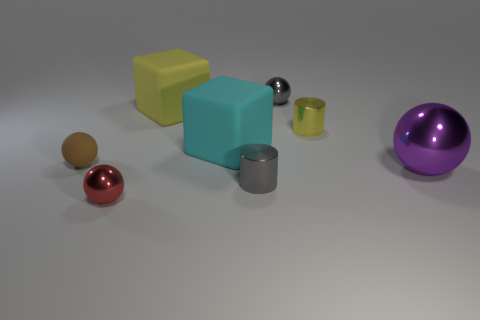Do the rubber object that is to the left of the red metallic ball and the large yellow rubber object have the same size?
Offer a very short reply. No. Is there a rubber cube of the same color as the big shiny object?
Your answer should be very brief. No. There is a gray ball that is made of the same material as the red thing; what is its size?
Ensure brevity in your answer.  Small. Is the number of yellow objects that are right of the tiny yellow cylinder greater than the number of cylinders on the right side of the tiny rubber sphere?
Offer a very short reply. No. What number of other objects are there of the same material as the large cyan block?
Provide a succinct answer. 2. Are the small sphere on the left side of the small red object and the gray sphere made of the same material?
Keep it short and to the point. No. What is the shape of the yellow metal thing?
Your answer should be compact. Cylinder. Are there more matte objects that are behind the big yellow thing than yellow cylinders?
Provide a succinct answer. No. Is there any other thing that has the same shape as the purple thing?
Your answer should be compact. Yes. What is the color of the matte thing that is the same shape as the purple shiny thing?
Provide a short and direct response. Brown. 